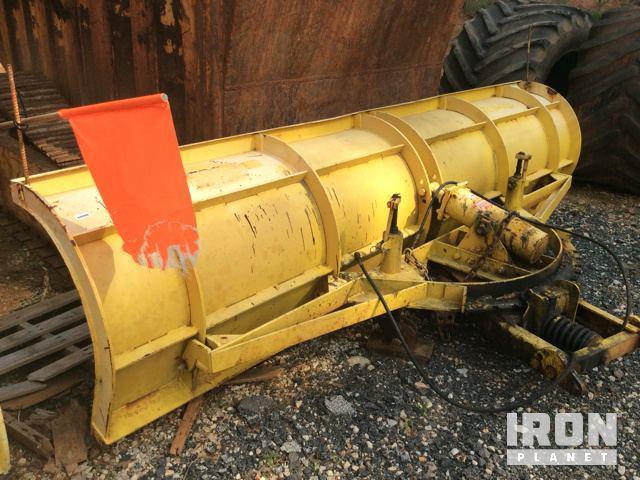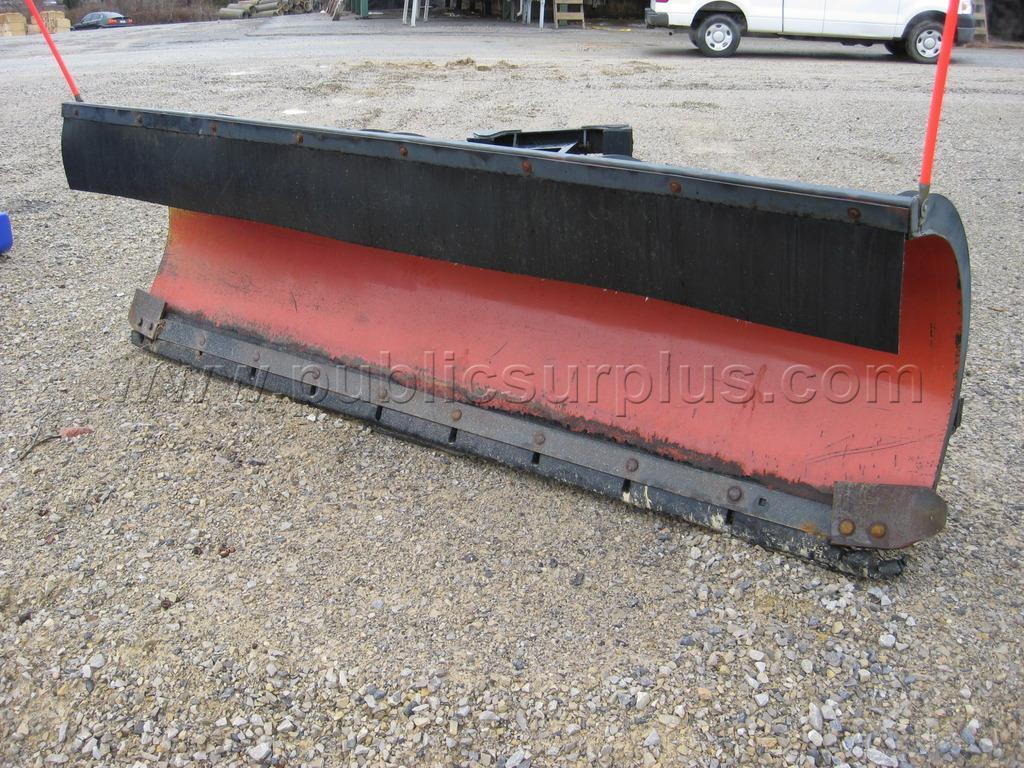The first image is the image on the left, the second image is the image on the right. Assess this claim about the two images: "The left image shows an unattached yellow snow plow with its back side facing the camera.". Correct or not? Answer yes or no. Yes. 